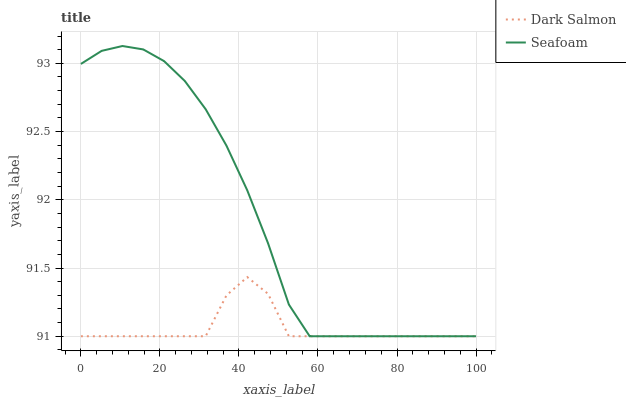Does Dark Salmon have the minimum area under the curve?
Answer yes or no. Yes. Does Seafoam have the maximum area under the curve?
Answer yes or no. Yes. Does Seafoam have the minimum area under the curve?
Answer yes or no. No. Is Seafoam the smoothest?
Answer yes or no. Yes. Is Dark Salmon the roughest?
Answer yes or no. Yes. Is Seafoam the roughest?
Answer yes or no. No. Does Dark Salmon have the lowest value?
Answer yes or no. Yes. Does Seafoam have the highest value?
Answer yes or no. Yes. Does Dark Salmon intersect Seafoam?
Answer yes or no. Yes. Is Dark Salmon less than Seafoam?
Answer yes or no. No. Is Dark Salmon greater than Seafoam?
Answer yes or no. No. 